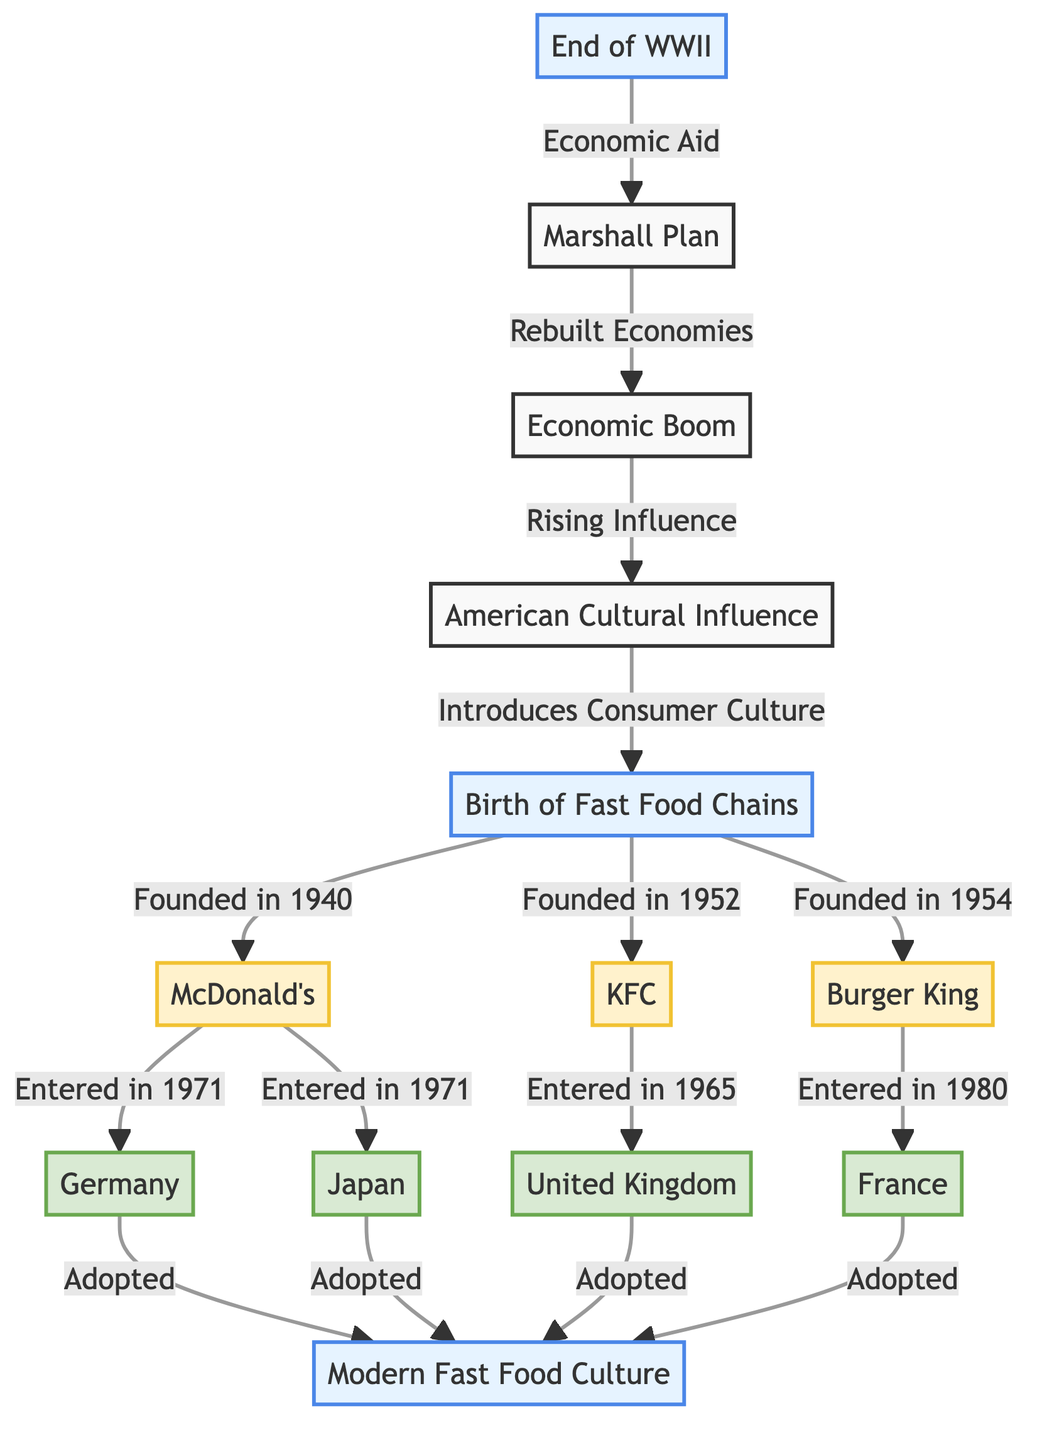What event marks the beginning of the post-war spread of American fast food culture? The diagram shows "End of WWII" as the initiating event that leads to the spread of American fast food culture.
Answer: End of WWII Which country adopted modern fast food culture last among the ones listed? The diagram indicates that among the countries listed, Burger King entered France in 1980, which shows a later timeline compared to the others.
Answer: France How many American fast food chains are mentioned in the diagram? The diagram lists three American fast food chains: McDonald's, KFC, and Burger King. Thus, the total number is three.
Answer: 3 When did McDonald's enter Japan? According to the diagram, McDonald's entered Japan in 1971.
Answer: 1971 Which country received KFC in 1965? The diagram shows KFC entered the UK in 1965, making it the correct answer to the question.
Answer: UK What influenced the birth of fast food chains? The diagram states that American cultural influence introduced consumer culture, which was a significant factor leading to the birth of fast food chains.
Answer: American Cultural Influence How many events are represented in the diagram? By counting the labeled events in the diagram—namely, "End of WWII," "Birth of Fast Food Chains," and "Modern Fast Food Culture"—we find there are four distinct events listed.
Answer: 4 In which year was KFC founded? The diagram indicates that KFC was founded in 1952.
Answer: 1952 What role did the Marshall Plan play according to the diagram? The diagram connects the Marshall Plan to the economic aid provided post-WWII, leading to the rebuilding of economies. Therefore, it played a role in facilitating economic growth.
Answer: Economic Aid 